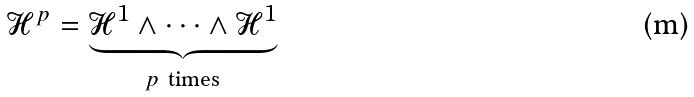Convert formula to latex. <formula><loc_0><loc_0><loc_500><loc_500>\mathcal { H } ^ { p } = \underbrace { \mathcal { H } ^ { 1 } \wedge \dots \wedge \mathcal { H } ^ { 1 } } _ { p \ \text {times} }</formula> 